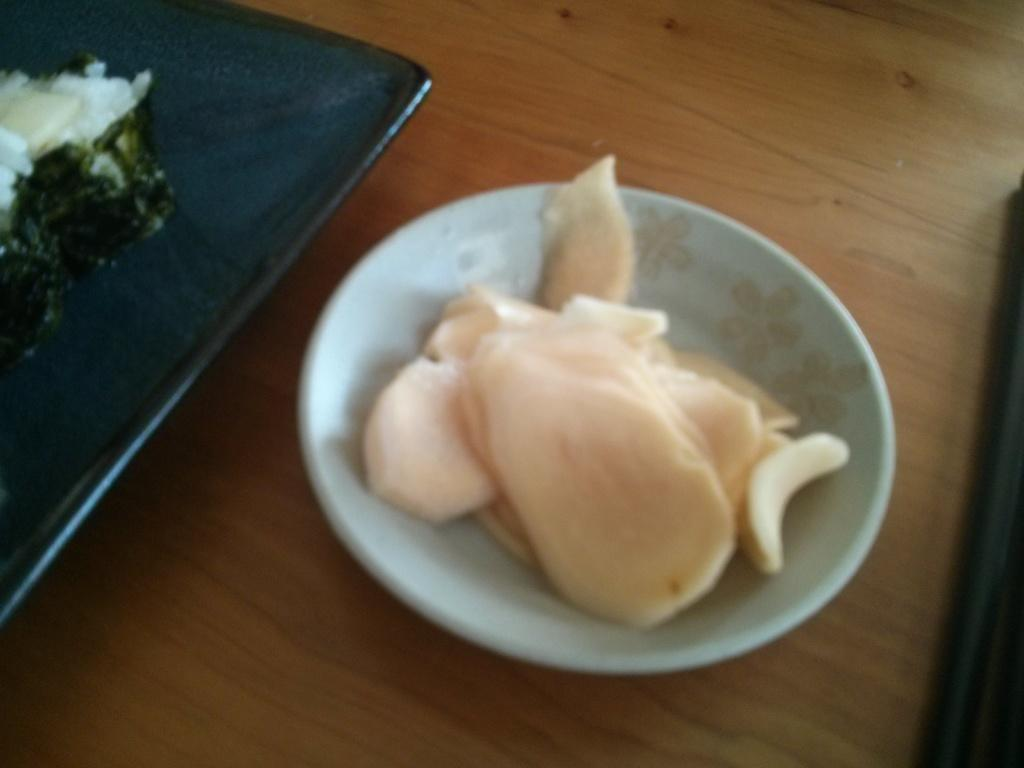What type of container is holding food items in the image? There is a bowl holding food items in the image. Are there any other containers with food items in the image? Yes, there is a plate with food items in the image. Where are the bowl and plate located? The bowl and plate are on a wooden board. What type of honey is being used to express anger in the image? There is no honey present in the image, nor is there any expression of anger. 